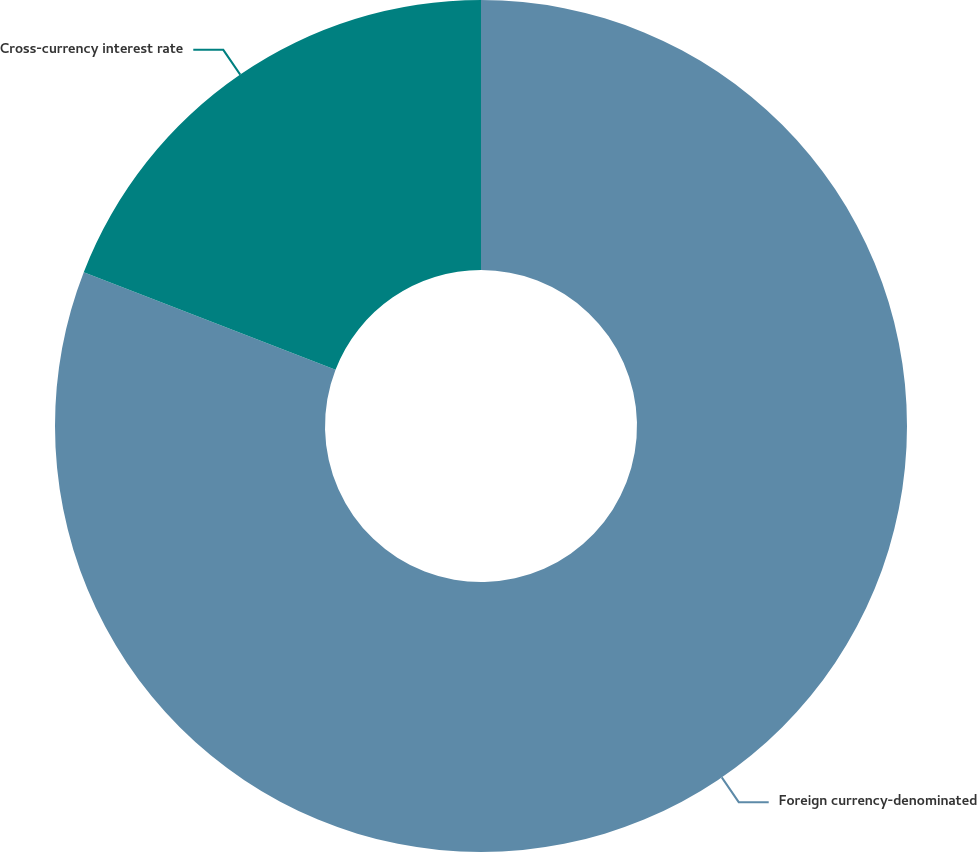Convert chart to OTSL. <chart><loc_0><loc_0><loc_500><loc_500><pie_chart><fcel>Foreign currency-denominated<fcel>Cross-currency interest rate<nl><fcel>80.88%<fcel>19.12%<nl></chart> 